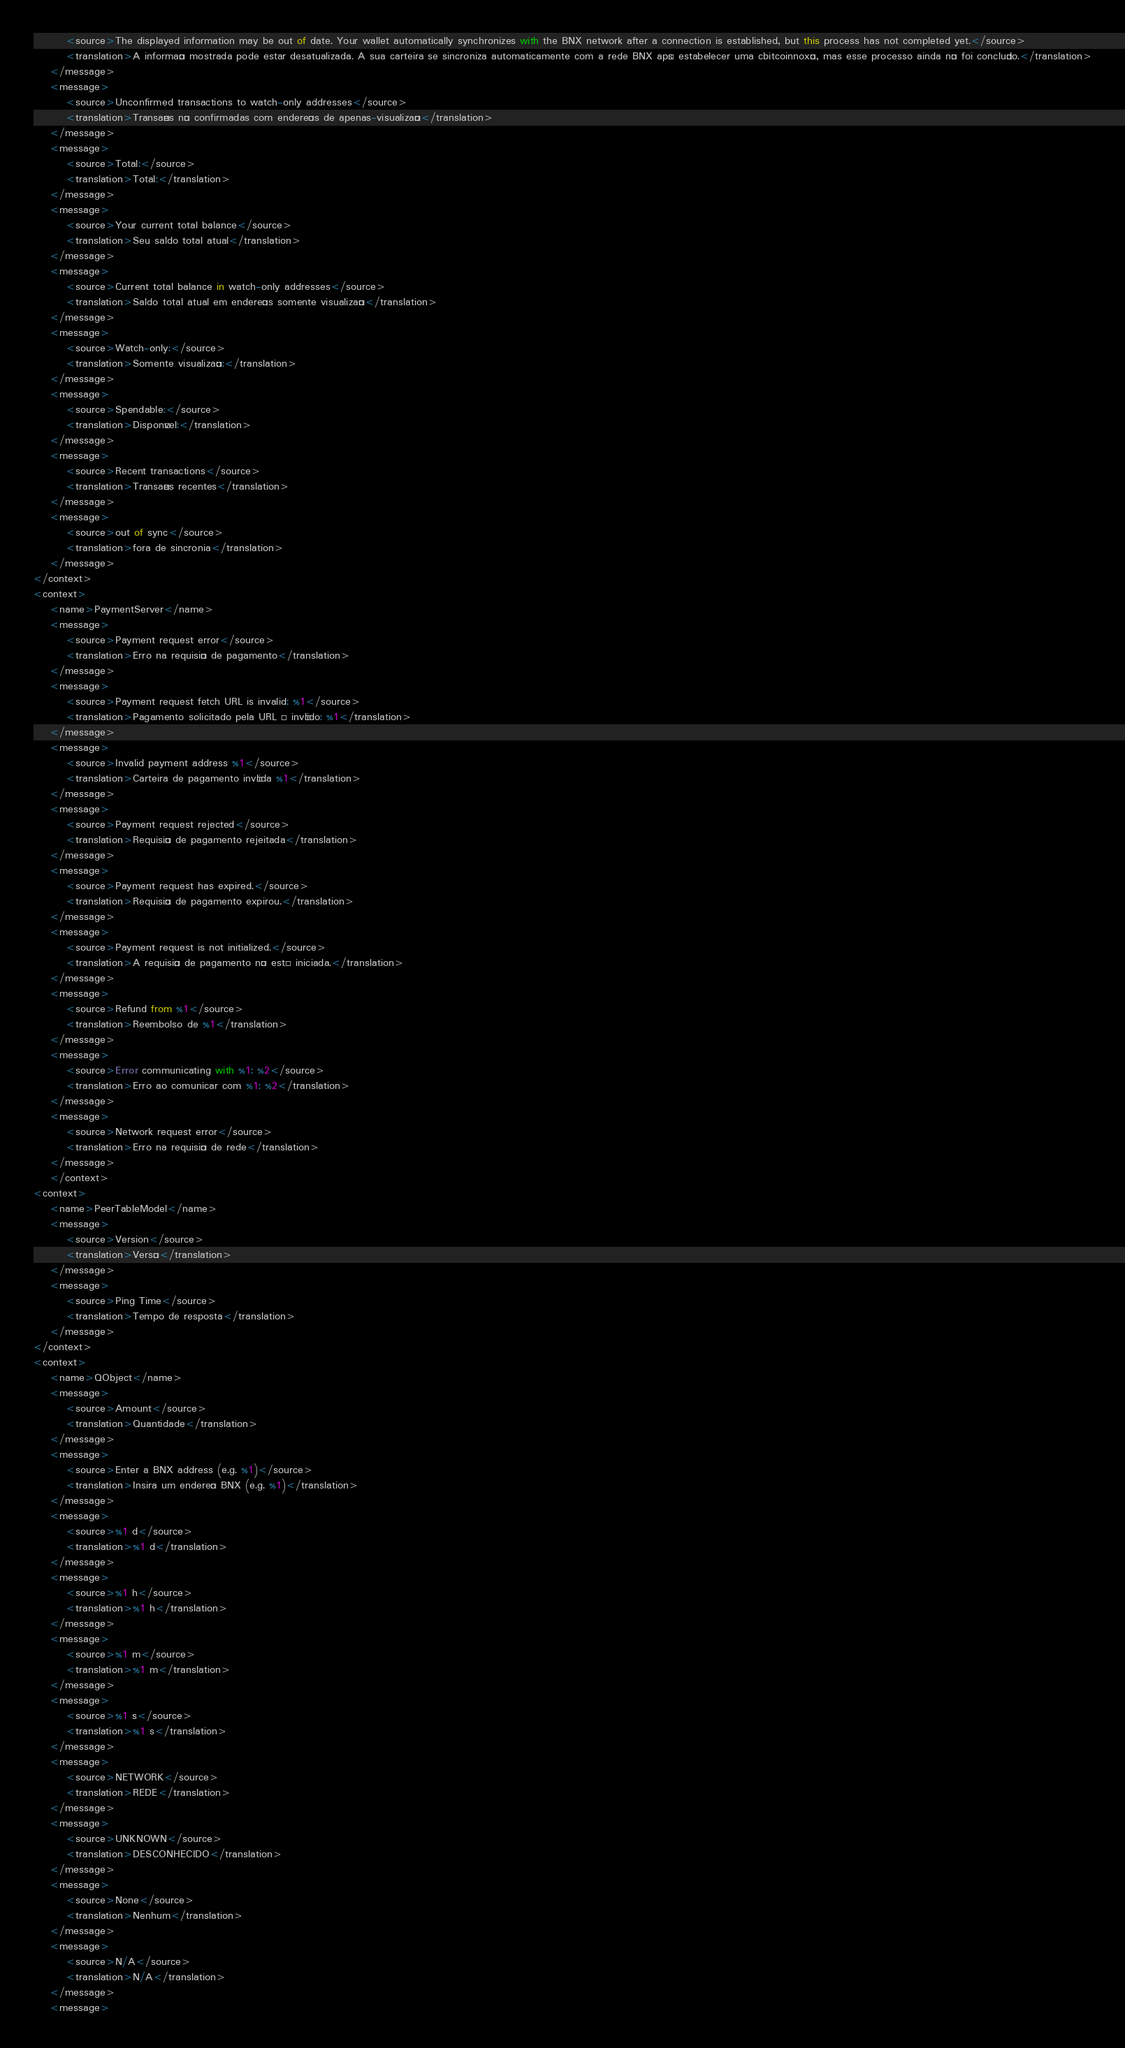<code> <loc_0><loc_0><loc_500><loc_500><_TypeScript_>        <source>The displayed information may be out of date. Your wallet automatically synchronizes with the BNX network after a connection is established, but this process has not completed yet.</source>
        <translation>A informação mostrada pode estar desatualizada. A sua carteira se sincroniza automaticamente com a rede BNX após estabelecer uma cbitcoinnoxão, mas esse processo ainda não foi concluído.</translation>
    </message>
    <message>
        <source>Unconfirmed transactions to watch-only addresses</source>
        <translation>Transações não confirmadas com endereços de apenas-visualização</translation>
    </message>
    <message>
        <source>Total:</source>
        <translation>Total:</translation>
    </message>
    <message>
        <source>Your current total balance</source>
        <translation>Seu saldo total atual</translation>
    </message>
    <message>
        <source>Current total balance in watch-only addresses</source>
        <translation>Saldo total atual em endereços somente visualização</translation>
    </message>
    <message>
        <source>Watch-only:</source>
        <translation>Somente visualização:</translation>
    </message>
    <message>
        <source>Spendable:</source>
        <translation>Disponível:</translation>
    </message>
    <message>
        <source>Recent transactions</source>
        <translation>Transações recentes</translation>
    </message>
    <message>
        <source>out of sync</source>
        <translation>fora de sincronia</translation>
    </message>
</context>
<context>
    <name>PaymentServer</name>
    <message>
        <source>Payment request error</source>
        <translation>Erro na requisição de pagamento</translation>
    </message>
    <message>
        <source>Payment request fetch URL is invalid: %1</source>
        <translation>Pagamento solicitado pela URL é inválido: %1</translation>
    </message>
    <message>
        <source>Invalid payment address %1</source>
        <translation>Carteira de pagamento inválida %1</translation>
    </message>
    <message>
        <source>Payment request rejected</source>
        <translation>Requisição de pagamento rejeitada</translation>
    </message>
    <message>
        <source>Payment request has expired.</source>
        <translation>Requisição de pagamento expirou.</translation>
    </message>
    <message>
        <source>Payment request is not initialized.</source>
        <translation>A requisição de pagamento não está iniciada.</translation>
    </message>
    <message>
        <source>Refund from %1</source>
        <translation>Reembolso de %1</translation>
    </message>
    <message>
        <source>Error communicating with %1: %2</source>
        <translation>Erro ao comunicar com %1: %2</translation>
    </message>
    <message>
        <source>Network request error</source>
        <translation>Erro na requisição de rede</translation>
    </message>
    </context>
<context>
    <name>PeerTableModel</name>
    <message>
        <source>Version</source>
        <translation>Versão</translation>
    </message>
    <message>
        <source>Ping Time</source>
        <translation>Tempo de resposta</translation>
    </message>
</context>
<context>
    <name>QObject</name>
    <message>
        <source>Amount</source>
        <translation>Quantidade</translation>
    </message>
    <message>
        <source>Enter a BNX address (e.g. %1)</source>
        <translation>Insira um endereço BNX (e.g. %1)</translation>
    </message>
    <message>
        <source>%1 d</source>
        <translation>%1 d</translation>
    </message>
    <message>
        <source>%1 h</source>
        <translation>%1 h</translation>
    </message>
    <message>
        <source>%1 m</source>
        <translation>%1 m</translation>
    </message>
    <message>
        <source>%1 s</source>
        <translation>%1 s</translation>
    </message>
    <message>
        <source>NETWORK</source>
        <translation>REDE</translation>
    </message>
    <message>
        <source>UNKNOWN</source>
        <translation>DESCONHECIDO</translation>
    </message>
    <message>
        <source>None</source>
        <translation>Nenhum</translation>
    </message>
    <message>
        <source>N/A</source>
        <translation>N/A</translation>
    </message>
    <message></code> 